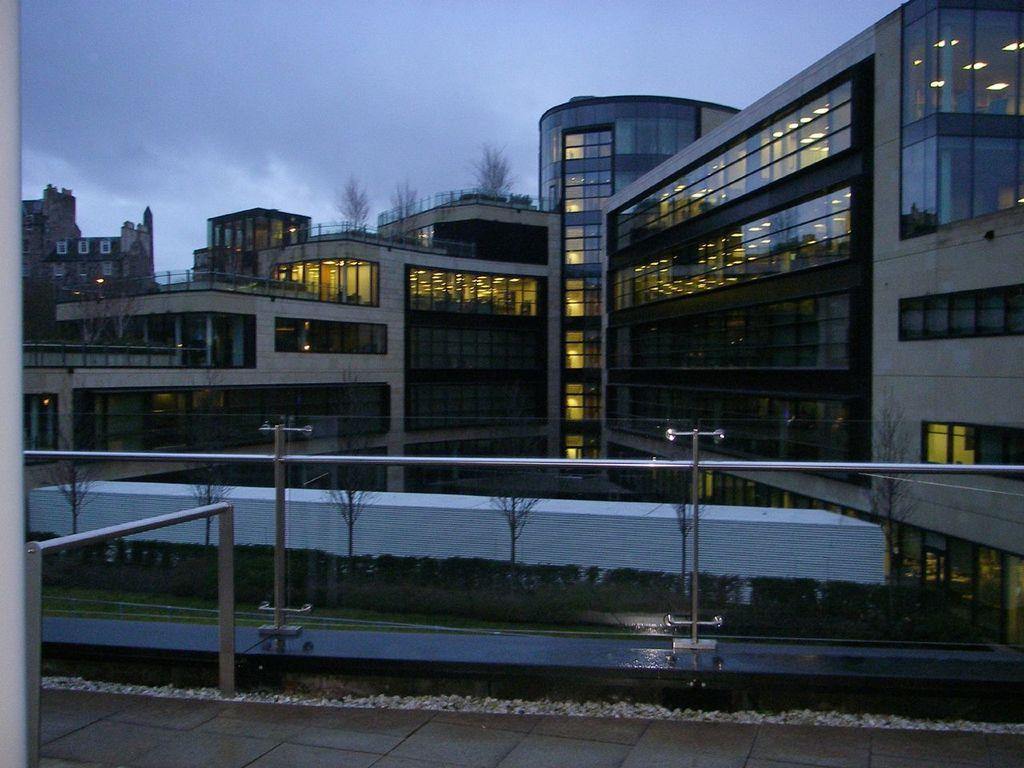What type of railing can be seen in the image? There is a glass railing in the image. What kind of buildings are visible in the image? There are glass buildings in the image. What is the condition of the trees in the image? Dry trees are present in the image. How would you describe the sky in the background of the image? The sky in the background is dark. What type of yarn is being used to transport the view in the image? There is no yarn or transportation of a view present in the image. What type of view can be seen from the glass railing in the image? The image does not provide a clear view of the surroundings, so it is difficult to describe the view from the glass railing. 